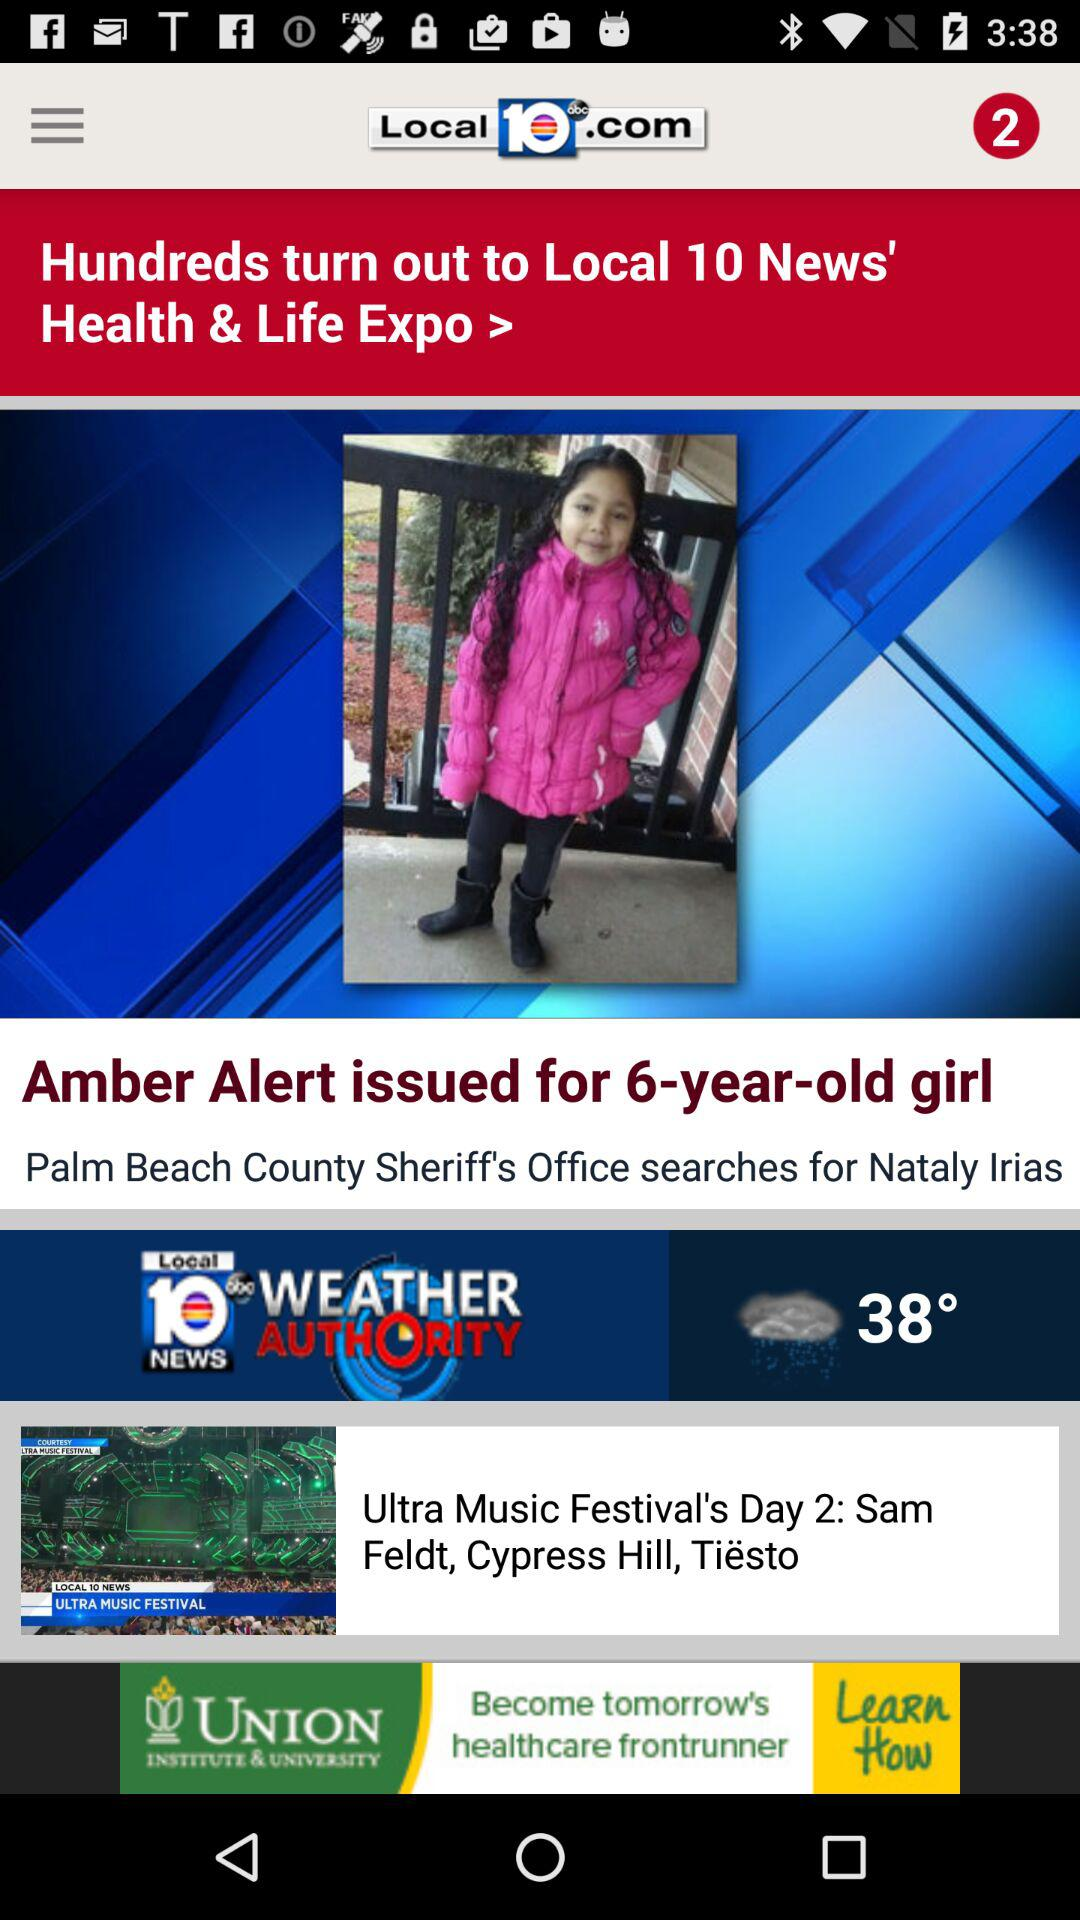What is the age of the girl? The girl is 6 years old. 